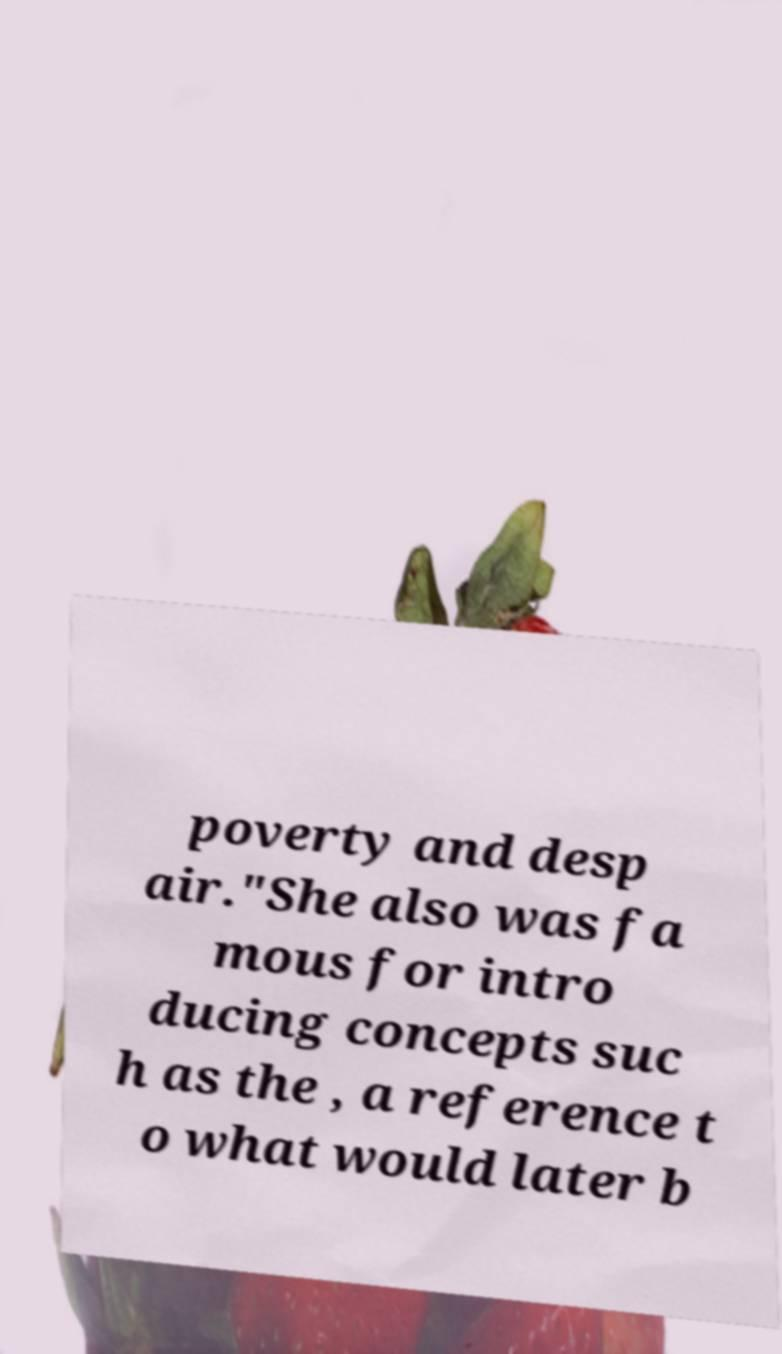Please identify and transcribe the text found in this image. poverty and desp air."She also was fa mous for intro ducing concepts suc h as the , a reference t o what would later b 